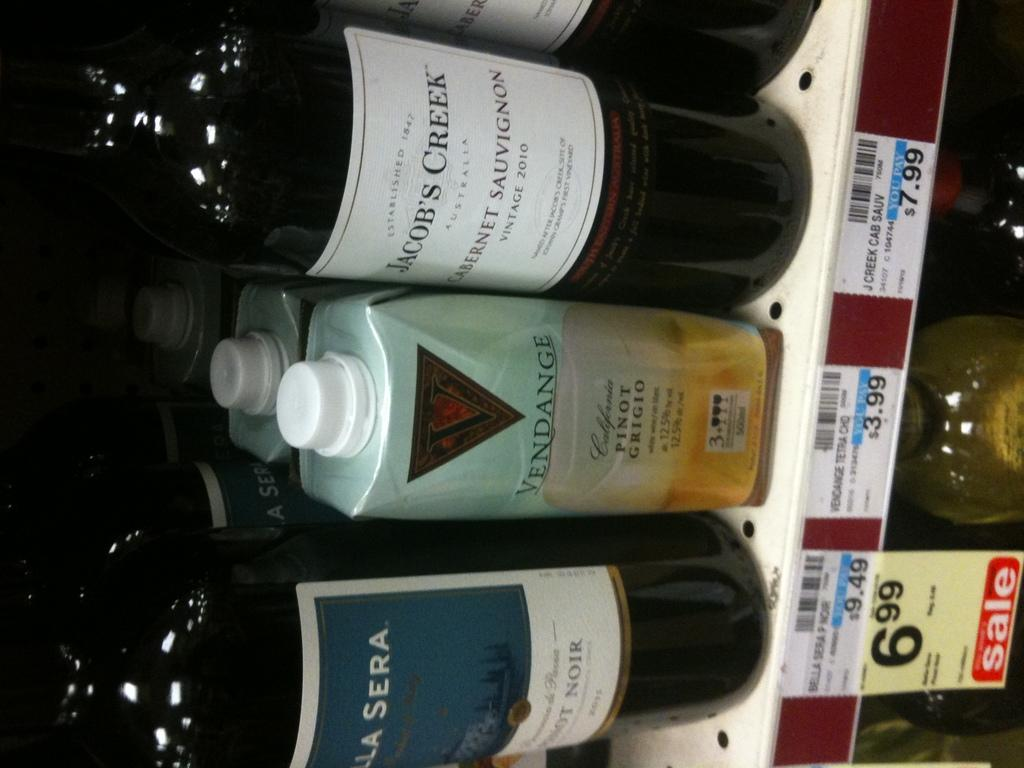<image>
Relay a brief, clear account of the picture shown. A bottle of Jacob's Creek wine is on the shelf of a store. 